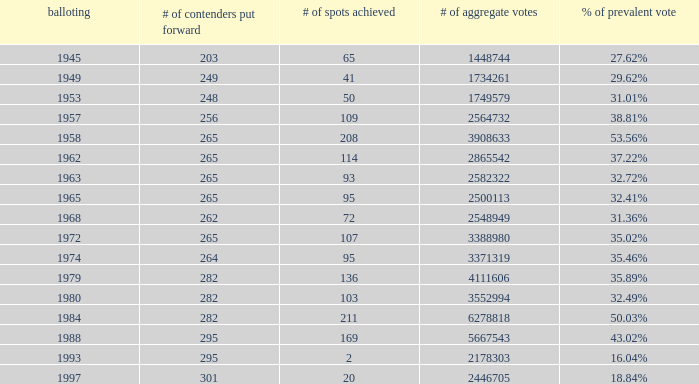In which election year were 262 candidates nominated? 1.0. 